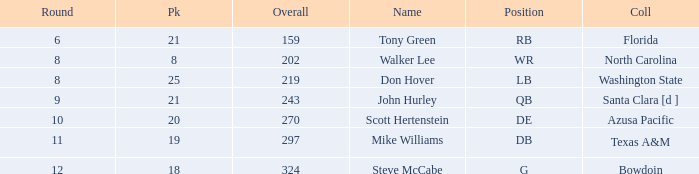How many overalls have a pick greater than 19, with florida as the college? 159.0. 